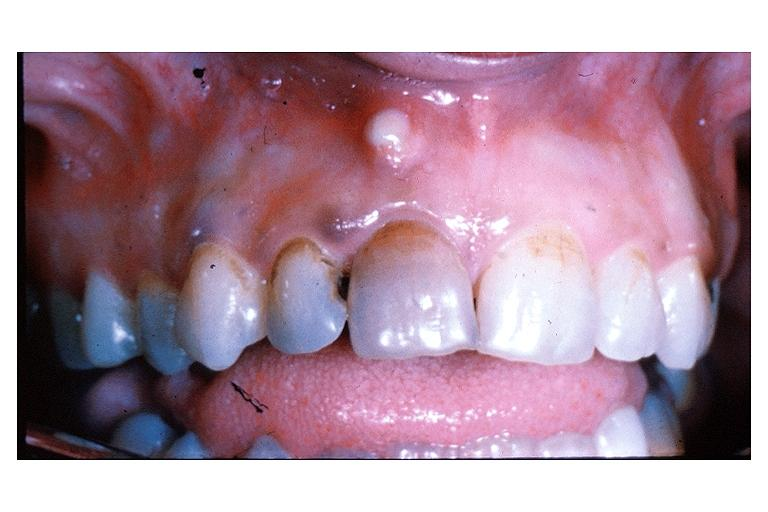what is present?
Answer the question using a single word or phrase. Oral 